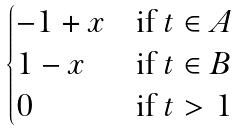Convert formula to latex. <formula><loc_0><loc_0><loc_500><loc_500>\begin{cases} - 1 + x & \text {if } t \in A \\ 1 - x & \text {if } t \in B \\ 0 & \text {if } t > 1 \end{cases}</formula> 